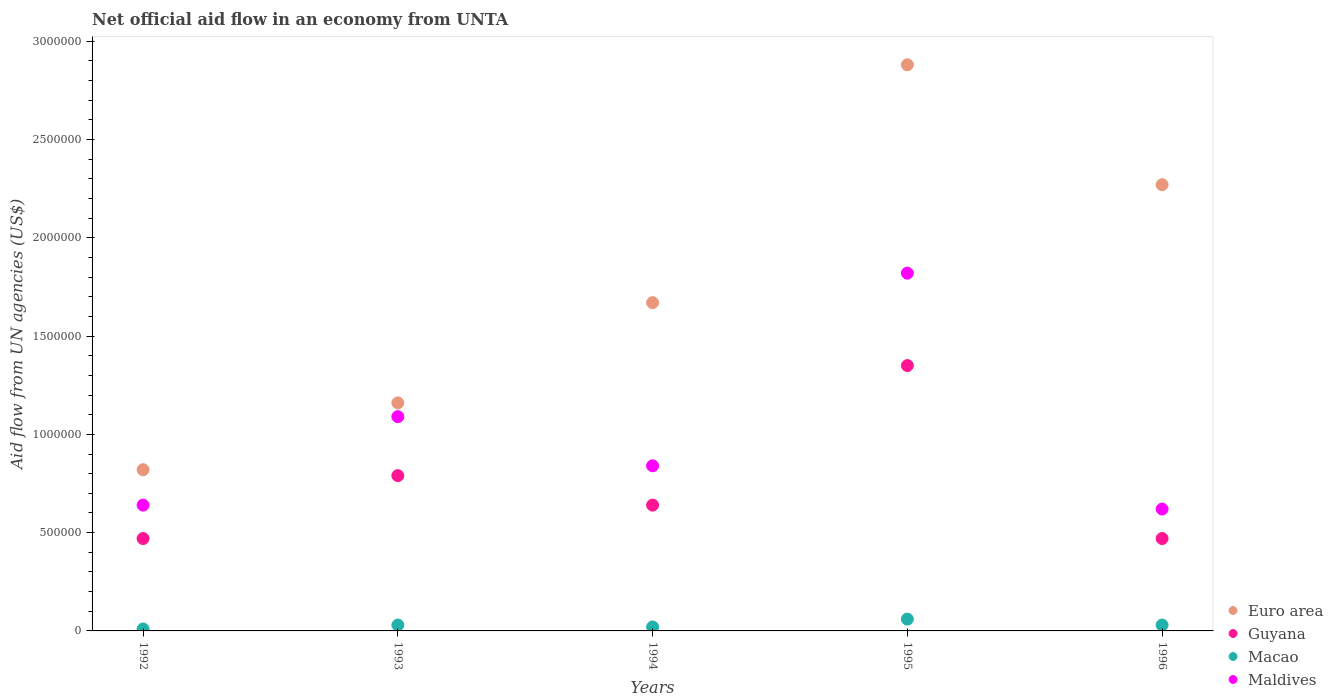What is the net official aid flow in Macao in 1993?
Make the answer very short. 3.00e+04. Across all years, what is the maximum net official aid flow in Guyana?
Ensure brevity in your answer.  1.35e+06. Across all years, what is the minimum net official aid flow in Maldives?
Give a very brief answer. 6.20e+05. In which year was the net official aid flow in Guyana maximum?
Ensure brevity in your answer.  1995. In which year was the net official aid flow in Guyana minimum?
Give a very brief answer. 1992. What is the total net official aid flow in Guyana in the graph?
Keep it short and to the point. 3.72e+06. What is the difference between the net official aid flow in Maldives in 1994 and that in 1995?
Provide a short and direct response. -9.80e+05. What is the difference between the net official aid flow in Guyana in 1994 and the net official aid flow in Macao in 1996?
Offer a very short reply. 6.10e+05. What is the average net official aid flow in Maldives per year?
Your answer should be compact. 1.00e+06. What is the ratio of the net official aid flow in Maldives in 1992 to that in 1996?
Your answer should be compact. 1.03. Is the difference between the net official aid flow in Maldives in 1993 and 1995 greater than the difference between the net official aid flow in Guyana in 1993 and 1995?
Your response must be concise. No. What is the difference between the highest and the second highest net official aid flow in Macao?
Offer a very short reply. 3.00e+04. Does the net official aid flow in Guyana monotonically increase over the years?
Provide a succinct answer. No. How many years are there in the graph?
Your response must be concise. 5. Where does the legend appear in the graph?
Offer a very short reply. Bottom right. What is the title of the graph?
Ensure brevity in your answer.  Net official aid flow in an economy from UNTA. Does "Poland" appear as one of the legend labels in the graph?
Offer a very short reply. No. What is the label or title of the Y-axis?
Give a very brief answer. Aid flow from UN agencies (US$). What is the Aid flow from UN agencies (US$) in Euro area in 1992?
Make the answer very short. 8.20e+05. What is the Aid flow from UN agencies (US$) of Guyana in 1992?
Your response must be concise. 4.70e+05. What is the Aid flow from UN agencies (US$) in Macao in 1992?
Give a very brief answer. 10000. What is the Aid flow from UN agencies (US$) of Maldives in 1992?
Your answer should be compact. 6.40e+05. What is the Aid flow from UN agencies (US$) in Euro area in 1993?
Provide a short and direct response. 1.16e+06. What is the Aid flow from UN agencies (US$) of Guyana in 1993?
Offer a very short reply. 7.90e+05. What is the Aid flow from UN agencies (US$) of Maldives in 1993?
Offer a very short reply. 1.09e+06. What is the Aid flow from UN agencies (US$) in Euro area in 1994?
Your response must be concise. 1.67e+06. What is the Aid flow from UN agencies (US$) in Guyana in 1994?
Keep it short and to the point. 6.40e+05. What is the Aid flow from UN agencies (US$) in Maldives in 1994?
Your answer should be very brief. 8.40e+05. What is the Aid flow from UN agencies (US$) in Euro area in 1995?
Your answer should be compact. 2.88e+06. What is the Aid flow from UN agencies (US$) of Guyana in 1995?
Your answer should be compact. 1.35e+06. What is the Aid flow from UN agencies (US$) of Macao in 1995?
Make the answer very short. 6.00e+04. What is the Aid flow from UN agencies (US$) in Maldives in 1995?
Make the answer very short. 1.82e+06. What is the Aid flow from UN agencies (US$) of Euro area in 1996?
Make the answer very short. 2.27e+06. What is the Aid flow from UN agencies (US$) of Macao in 1996?
Make the answer very short. 3.00e+04. What is the Aid flow from UN agencies (US$) in Maldives in 1996?
Give a very brief answer. 6.20e+05. Across all years, what is the maximum Aid flow from UN agencies (US$) of Euro area?
Offer a very short reply. 2.88e+06. Across all years, what is the maximum Aid flow from UN agencies (US$) of Guyana?
Keep it short and to the point. 1.35e+06. Across all years, what is the maximum Aid flow from UN agencies (US$) in Macao?
Your answer should be compact. 6.00e+04. Across all years, what is the maximum Aid flow from UN agencies (US$) in Maldives?
Your response must be concise. 1.82e+06. Across all years, what is the minimum Aid flow from UN agencies (US$) of Euro area?
Make the answer very short. 8.20e+05. Across all years, what is the minimum Aid flow from UN agencies (US$) of Guyana?
Provide a succinct answer. 4.70e+05. Across all years, what is the minimum Aid flow from UN agencies (US$) of Macao?
Offer a terse response. 10000. Across all years, what is the minimum Aid flow from UN agencies (US$) of Maldives?
Provide a short and direct response. 6.20e+05. What is the total Aid flow from UN agencies (US$) in Euro area in the graph?
Provide a short and direct response. 8.80e+06. What is the total Aid flow from UN agencies (US$) in Guyana in the graph?
Keep it short and to the point. 3.72e+06. What is the total Aid flow from UN agencies (US$) of Macao in the graph?
Your response must be concise. 1.50e+05. What is the total Aid flow from UN agencies (US$) of Maldives in the graph?
Keep it short and to the point. 5.01e+06. What is the difference between the Aid flow from UN agencies (US$) of Euro area in 1992 and that in 1993?
Ensure brevity in your answer.  -3.40e+05. What is the difference between the Aid flow from UN agencies (US$) in Guyana in 1992 and that in 1993?
Make the answer very short. -3.20e+05. What is the difference between the Aid flow from UN agencies (US$) of Macao in 1992 and that in 1993?
Ensure brevity in your answer.  -2.00e+04. What is the difference between the Aid flow from UN agencies (US$) in Maldives in 1992 and that in 1993?
Offer a terse response. -4.50e+05. What is the difference between the Aid flow from UN agencies (US$) of Euro area in 1992 and that in 1994?
Offer a terse response. -8.50e+05. What is the difference between the Aid flow from UN agencies (US$) of Guyana in 1992 and that in 1994?
Keep it short and to the point. -1.70e+05. What is the difference between the Aid flow from UN agencies (US$) of Euro area in 1992 and that in 1995?
Your answer should be very brief. -2.06e+06. What is the difference between the Aid flow from UN agencies (US$) in Guyana in 1992 and that in 1995?
Make the answer very short. -8.80e+05. What is the difference between the Aid flow from UN agencies (US$) of Macao in 1992 and that in 1995?
Make the answer very short. -5.00e+04. What is the difference between the Aid flow from UN agencies (US$) of Maldives in 1992 and that in 1995?
Give a very brief answer. -1.18e+06. What is the difference between the Aid flow from UN agencies (US$) in Euro area in 1992 and that in 1996?
Offer a terse response. -1.45e+06. What is the difference between the Aid flow from UN agencies (US$) of Guyana in 1992 and that in 1996?
Ensure brevity in your answer.  0. What is the difference between the Aid flow from UN agencies (US$) in Macao in 1992 and that in 1996?
Make the answer very short. -2.00e+04. What is the difference between the Aid flow from UN agencies (US$) of Maldives in 1992 and that in 1996?
Keep it short and to the point. 2.00e+04. What is the difference between the Aid flow from UN agencies (US$) of Euro area in 1993 and that in 1994?
Give a very brief answer. -5.10e+05. What is the difference between the Aid flow from UN agencies (US$) of Guyana in 1993 and that in 1994?
Offer a terse response. 1.50e+05. What is the difference between the Aid flow from UN agencies (US$) of Euro area in 1993 and that in 1995?
Your answer should be very brief. -1.72e+06. What is the difference between the Aid flow from UN agencies (US$) in Guyana in 1993 and that in 1995?
Provide a succinct answer. -5.60e+05. What is the difference between the Aid flow from UN agencies (US$) of Macao in 1993 and that in 1995?
Provide a succinct answer. -3.00e+04. What is the difference between the Aid flow from UN agencies (US$) in Maldives in 1993 and that in 1995?
Your response must be concise. -7.30e+05. What is the difference between the Aid flow from UN agencies (US$) of Euro area in 1993 and that in 1996?
Make the answer very short. -1.11e+06. What is the difference between the Aid flow from UN agencies (US$) in Guyana in 1993 and that in 1996?
Offer a terse response. 3.20e+05. What is the difference between the Aid flow from UN agencies (US$) in Macao in 1993 and that in 1996?
Your response must be concise. 0. What is the difference between the Aid flow from UN agencies (US$) in Euro area in 1994 and that in 1995?
Your answer should be very brief. -1.21e+06. What is the difference between the Aid flow from UN agencies (US$) of Guyana in 1994 and that in 1995?
Ensure brevity in your answer.  -7.10e+05. What is the difference between the Aid flow from UN agencies (US$) of Macao in 1994 and that in 1995?
Provide a short and direct response. -4.00e+04. What is the difference between the Aid flow from UN agencies (US$) in Maldives in 1994 and that in 1995?
Ensure brevity in your answer.  -9.80e+05. What is the difference between the Aid flow from UN agencies (US$) of Euro area in 1994 and that in 1996?
Offer a very short reply. -6.00e+05. What is the difference between the Aid flow from UN agencies (US$) in Euro area in 1995 and that in 1996?
Provide a short and direct response. 6.10e+05. What is the difference between the Aid flow from UN agencies (US$) in Guyana in 1995 and that in 1996?
Keep it short and to the point. 8.80e+05. What is the difference between the Aid flow from UN agencies (US$) of Maldives in 1995 and that in 1996?
Keep it short and to the point. 1.20e+06. What is the difference between the Aid flow from UN agencies (US$) of Euro area in 1992 and the Aid flow from UN agencies (US$) of Guyana in 1993?
Offer a very short reply. 3.00e+04. What is the difference between the Aid flow from UN agencies (US$) in Euro area in 1992 and the Aid flow from UN agencies (US$) in Macao in 1993?
Provide a short and direct response. 7.90e+05. What is the difference between the Aid flow from UN agencies (US$) in Euro area in 1992 and the Aid flow from UN agencies (US$) in Maldives in 1993?
Provide a succinct answer. -2.70e+05. What is the difference between the Aid flow from UN agencies (US$) of Guyana in 1992 and the Aid flow from UN agencies (US$) of Macao in 1993?
Your answer should be very brief. 4.40e+05. What is the difference between the Aid flow from UN agencies (US$) of Guyana in 1992 and the Aid flow from UN agencies (US$) of Maldives in 1993?
Provide a short and direct response. -6.20e+05. What is the difference between the Aid flow from UN agencies (US$) in Macao in 1992 and the Aid flow from UN agencies (US$) in Maldives in 1993?
Ensure brevity in your answer.  -1.08e+06. What is the difference between the Aid flow from UN agencies (US$) in Euro area in 1992 and the Aid flow from UN agencies (US$) in Maldives in 1994?
Provide a short and direct response. -2.00e+04. What is the difference between the Aid flow from UN agencies (US$) in Guyana in 1992 and the Aid flow from UN agencies (US$) in Macao in 1994?
Offer a terse response. 4.50e+05. What is the difference between the Aid flow from UN agencies (US$) of Guyana in 1992 and the Aid flow from UN agencies (US$) of Maldives in 1994?
Provide a succinct answer. -3.70e+05. What is the difference between the Aid flow from UN agencies (US$) of Macao in 1992 and the Aid flow from UN agencies (US$) of Maldives in 1994?
Offer a terse response. -8.30e+05. What is the difference between the Aid flow from UN agencies (US$) of Euro area in 1992 and the Aid flow from UN agencies (US$) of Guyana in 1995?
Offer a very short reply. -5.30e+05. What is the difference between the Aid flow from UN agencies (US$) in Euro area in 1992 and the Aid flow from UN agencies (US$) in Macao in 1995?
Keep it short and to the point. 7.60e+05. What is the difference between the Aid flow from UN agencies (US$) of Euro area in 1992 and the Aid flow from UN agencies (US$) of Maldives in 1995?
Ensure brevity in your answer.  -1.00e+06. What is the difference between the Aid flow from UN agencies (US$) in Guyana in 1992 and the Aid flow from UN agencies (US$) in Macao in 1995?
Keep it short and to the point. 4.10e+05. What is the difference between the Aid flow from UN agencies (US$) in Guyana in 1992 and the Aid flow from UN agencies (US$) in Maldives in 1995?
Make the answer very short. -1.35e+06. What is the difference between the Aid flow from UN agencies (US$) of Macao in 1992 and the Aid flow from UN agencies (US$) of Maldives in 1995?
Ensure brevity in your answer.  -1.81e+06. What is the difference between the Aid flow from UN agencies (US$) of Euro area in 1992 and the Aid flow from UN agencies (US$) of Macao in 1996?
Your response must be concise. 7.90e+05. What is the difference between the Aid flow from UN agencies (US$) of Euro area in 1992 and the Aid flow from UN agencies (US$) of Maldives in 1996?
Your response must be concise. 2.00e+05. What is the difference between the Aid flow from UN agencies (US$) in Macao in 1992 and the Aid flow from UN agencies (US$) in Maldives in 1996?
Keep it short and to the point. -6.10e+05. What is the difference between the Aid flow from UN agencies (US$) in Euro area in 1993 and the Aid flow from UN agencies (US$) in Guyana in 1994?
Ensure brevity in your answer.  5.20e+05. What is the difference between the Aid flow from UN agencies (US$) in Euro area in 1993 and the Aid flow from UN agencies (US$) in Macao in 1994?
Offer a terse response. 1.14e+06. What is the difference between the Aid flow from UN agencies (US$) of Guyana in 1993 and the Aid flow from UN agencies (US$) of Macao in 1994?
Your response must be concise. 7.70e+05. What is the difference between the Aid flow from UN agencies (US$) in Macao in 1993 and the Aid flow from UN agencies (US$) in Maldives in 1994?
Ensure brevity in your answer.  -8.10e+05. What is the difference between the Aid flow from UN agencies (US$) of Euro area in 1993 and the Aid flow from UN agencies (US$) of Guyana in 1995?
Keep it short and to the point. -1.90e+05. What is the difference between the Aid flow from UN agencies (US$) of Euro area in 1993 and the Aid flow from UN agencies (US$) of Macao in 1995?
Keep it short and to the point. 1.10e+06. What is the difference between the Aid flow from UN agencies (US$) of Euro area in 1993 and the Aid flow from UN agencies (US$) of Maldives in 1995?
Your answer should be compact. -6.60e+05. What is the difference between the Aid flow from UN agencies (US$) of Guyana in 1993 and the Aid flow from UN agencies (US$) of Macao in 1995?
Offer a terse response. 7.30e+05. What is the difference between the Aid flow from UN agencies (US$) in Guyana in 1993 and the Aid flow from UN agencies (US$) in Maldives in 1995?
Give a very brief answer. -1.03e+06. What is the difference between the Aid flow from UN agencies (US$) of Macao in 1993 and the Aid flow from UN agencies (US$) of Maldives in 1995?
Give a very brief answer. -1.79e+06. What is the difference between the Aid flow from UN agencies (US$) in Euro area in 1993 and the Aid flow from UN agencies (US$) in Guyana in 1996?
Make the answer very short. 6.90e+05. What is the difference between the Aid flow from UN agencies (US$) of Euro area in 1993 and the Aid flow from UN agencies (US$) of Macao in 1996?
Provide a succinct answer. 1.13e+06. What is the difference between the Aid flow from UN agencies (US$) of Euro area in 1993 and the Aid flow from UN agencies (US$) of Maldives in 1996?
Provide a short and direct response. 5.40e+05. What is the difference between the Aid flow from UN agencies (US$) in Guyana in 1993 and the Aid flow from UN agencies (US$) in Macao in 1996?
Offer a terse response. 7.60e+05. What is the difference between the Aid flow from UN agencies (US$) of Macao in 1993 and the Aid flow from UN agencies (US$) of Maldives in 1996?
Give a very brief answer. -5.90e+05. What is the difference between the Aid flow from UN agencies (US$) of Euro area in 1994 and the Aid flow from UN agencies (US$) of Guyana in 1995?
Make the answer very short. 3.20e+05. What is the difference between the Aid flow from UN agencies (US$) of Euro area in 1994 and the Aid flow from UN agencies (US$) of Macao in 1995?
Give a very brief answer. 1.61e+06. What is the difference between the Aid flow from UN agencies (US$) of Euro area in 1994 and the Aid flow from UN agencies (US$) of Maldives in 1995?
Ensure brevity in your answer.  -1.50e+05. What is the difference between the Aid flow from UN agencies (US$) of Guyana in 1994 and the Aid flow from UN agencies (US$) of Macao in 1995?
Your response must be concise. 5.80e+05. What is the difference between the Aid flow from UN agencies (US$) of Guyana in 1994 and the Aid flow from UN agencies (US$) of Maldives in 1995?
Provide a short and direct response. -1.18e+06. What is the difference between the Aid flow from UN agencies (US$) in Macao in 1994 and the Aid flow from UN agencies (US$) in Maldives in 1995?
Your answer should be compact. -1.80e+06. What is the difference between the Aid flow from UN agencies (US$) of Euro area in 1994 and the Aid flow from UN agencies (US$) of Guyana in 1996?
Provide a short and direct response. 1.20e+06. What is the difference between the Aid flow from UN agencies (US$) of Euro area in 1994 and the Aid flow from UN agencies (US$) of Macao in 1996?
Make the answer very short. 1.64e+06. What is the difference between the Aid flow from UN agencies (US$) in Euro area in 1994 and the Aid flow from UN agencies (US$) in Maldives in 1996?
Give a very brief answer. 1.05e+06. What is the difference between the Aid flow from UN agencies (US$) of Guyana in 1994 and the Aid flow from UN agencies (US$) of Macao in 1996?
Keep it short and to the point. 6.10e+05. What is the difference between the Aid flow from UN agencies (US$) of Guyana in 1994 and the Aid flow from UN agencies (US$) of Maldives in 1996?
Make the answer very short. 2.00e+04. What is the difference between the Aid flow from UN agencies (US$) of Macao in 1994 and the Aid flow from UN agencies (US$) of Maldives in 1996?
Give a very brief answer. -6.00e+05. What is the difference between the Aid flow from UN agencies (US$) in Euro area in 1995 and the Aid flow from UN agencies (US$) in Guyana in 1996?
Your response must be concise. 2.41e+06. What is the difference between the Aid flow from UN agencies (US$) of Euro area in 1995 and the Aid flow from UN agencies (US$) of Macao in 1996?
Make the answer very short. 2.85e+06. What is the difference between the Aid flow from UN agencies (US$) of Euro area in 1995 and the Aid flow from UN agencies (US$) of Maldives in 1996?
Offer a very short reply. 2.26e+06. What is the difference between the Aid flow from UN agencies (US$) in Guyana in 1995 and the Aid flow from UN agencies (US$) in Macao in 1996?
Offer a terse response. 1.32e+06. What is the difference between the Aid flow from UN agencies (US$) in Guyana in 1995 and the Aid flow from UN agencies (US$) in Maldives in 1996?
Your answer should be very brief. 7.30e+05. What is the difference between the Aid flow from UN agencies (US$) in Macao in 1995 and the Aid flow from UN agencies (US$) in Maldives in 1996?
Provide a short and direct response. -5.60e+05. What is the average Aid flow from UN agencies (US$) of Euro area per year?
Offer a very short reply. 1.76e+06. What is the average Aid flow from UN agencies (US$) of Guyana per year?
Keep it short and to the point. 7.44e+05. What is the average Aid flow from UN agencies (US$) in Maldives per year?
Your response must be concise. 1.00e+06. In the year 1992, what is the difference between the Aid flow from UN agencies (US$) of Euro area and Aid flow from UN agencies (US$) of Macao?
Ensure brevity in your answer.  8.10e+05. In the year 1992, what is the difference between the Aid flow from UN agencies (US$) of Euro area and Aid flow from UN agencies (US$) of Maldives?
Your answer should be compact. 1.80e+05. In the year 1992, what is the difference between the Aid flow from UN agencies (US$) in Guyana and Aid flow from UN agencies (US$) in Maldives?
Offer a very short reply. -1.70e+05. In the year 1992, what is the difference between the Aid flow from UN agencies (US$) of Macao and Aid flow from UN agencies (US$) of Maldives?
Provide a succinct answer. -6.30e+05. In the year 1993, what is the difference between the Aid flow from UN agencies (US$) in Euro area and Aid flow from UN agencies (US$) in Guyana?
Give a very brief answer. 3.70e+05. In the year 1993, what is the difference between the Aid flow from UN agencies (US$) of Euro area and Aid flow from UN agencies (US$) of Macao?
Give a very brief answer. 1.13e+06. In the year 1993, what is the difference between the Aid flow from UN agencies (US$) of Euro area and Aid flow from UN agencies (US$) of Maldives?
Offer a terse response. 7.00e+04. In the year 1993, what is the difference between the Aid flow from UN agencies (US$) of Guyana and Aid flow from UN agencies (US$) of Macao?
Offer a terse response. 7.60e+05. In the year 1993, what is the difference between the Aid flow from UN agencies (US$) of Guyana and Aid flow from UN agencies (US$) of Maldives?
Make the answer very short. -3.00e+05. In the year 1993, what is the difference between the Aid flow from UN agencies (US$) in Macao and Aid flow from UN agencies (US$) in Maldives?
Make the answer very short. -1.06e+06. In the year 1994, what is the difference between the Aid flow from UN agencies (US$) in Euro area and Aid flow from UN agencies (US$) in Guyana?
Keep it short and to the point. 1.03e+06. In the year 1994, what is the difference between the Aid flow from UN agencies (US$) in Euro area and Aid flow from UN agencies (US$) in Macao?
Offer a terse response. 1.65e+06. In the year 1994, what is the difference between the Aid flow from UN agencies (US$) in Euro area and Aid flow from UN agencies (US$) in Maldives?
Make the answer very short. 8.30e+05. In the year 1994, what is the difference between the Aid flow from UN agencies (US$) of Guyana and Aid flow from UN agencies (US$) of Macao?
Keep it short and to the point. 6.20e+05. In the year 1994, what is the difference between the Aid flow from UN agencies (US$) of Macao and Aid flow from UN agencies (US$) of Maldives?
Your response must be concise. -8.20e+05. In the year 1995, what is the difference between the Aid flow from UN agencies (US$) of Euro area and Aid flow from UN agencies (US$) of Guyana?
Keep it short and to the point. 1.53e+06. In the year 1995, what is the difference between the Aid flow from UN agencies (US$) of Euro area and Aid flow from UN agencies (US$) of Macao?
Offer a terse response. 2.82e+06. In the year 1995, what is the difference between the Aid flow from UN agencies (US$) in Euro area and Aid flow from UN agencies (US$) in Maldives?
Give a very brief answer. 1.06e+06. In the year 1995, what is the difference between the Aid flow from UN agencies (US$) of Guyana and Aid flow from UN agencies (US$) of Macao?
Give a very brief answer. 1.29e+06. In the year 1995, what is the difference between the Aid flow from UN agencies (US$) in Guyana and Aid flow from UN agencies (US$) in Maldives?
Give a very brief answer. -4.70e+05. In the year 1995, what is the difference between the Aid flow from UN agencies (US$) of Macao and Aid flow from UN agencies (US$) of Maldives?
Give a very brief answer. -1.76e+06. In the year 1996, what is the difference between the Aid flow from UN agencies (US$) in Euro area and Aid flow from UN agencies (US$) in Guyana?
Your answer should be very brief. 1.80e+06. In the year 1996, what is the difference between the Aid flow from UN agencies (US$) of Euro area and Aid flow from UN agencies (US$) of Macao?
Your response must be concise. 2.24e+06. In the year 1996, what is the difference between the Aid flow from UN agencies (US$) of Euro area and Aid flow from UN agencies (US$) of Maldives?
Offer a very short reply. 1.65e+06. In the year 1996, what is the difference between the Aid flow from UN agencies (US$) in Macao and Aid flow from UN agencies (US$) in Maldives?
Provide a short and direct response. -5.90e+05. What is the ratio of the Aid flow from UN agencies (US$) of Euro area in 1992 to that in 1993?
Your response must be concise. 0.71. What is the ratio of the Aid flow from UN agencies (US$) in Guyana in 1992 to that in 1993?
Your answer should be very brief. 0.59. What is the ratio of the Aid flow from UN agencies (US$) in Macao in 1992 to that in 1993?
Offer a very short reply. 0.33. What is the ratio of the Aid flow from UN agencies (US$) of Maldives in 1992 to that in 1993?
Offer a very short reply. 0.59. What is the ratio of the Aid flow from UN agencies (US$) in Euro area in 1992 to that in 1994?
Provide a succinct answer. 0.49. What is the ratio of the Aid flow from UN agencies (US$) of Guyana in 1992 to that in 1994?
Keep it short and to the point. 0.73. What is the ratio of the Aid flow from UN agencies (US$) of Macao in 1992 to that in 1994?
Provide a succinct answer. 0.5. What is the ratio of the Aid flow from UN agencies (US$) of Maldives in 1992 to that in 1994?
Offer a terse response. 0.76. What is the ratio of the Aid flow from UN agencies (US$) of Euro area in 1992 to that in 1995?
Your answer should be compact. 0.28. What is the ratio of the Aid flow from UN agencies (US$) in Guyana in 1992 to that in 1995?
Make the answer very short. 0.35. What is the ratio of the Aid flow from UN agencies (US$) of Maldives in 1992 to that in 1995?
Your answer should be compact. 0.35. What is the ratio of the Aid flow from UN agencies (US$) of Euro area in 1992 to that in 1996?
Offer a terse response. 0.36. What is the ratio of the Aid flow from UN agencies (US$) in Maldives in 1992 to that in 1996?
Your response must be concise. 1.03. What is the ratio of the Aid flow from UN agencies (US$) in Euro area in 1993 to that in 1994?
Your answer should be very brief. 0.69. What is the ratio of the Aid flow from UN agencies (US$) of Guyana in 1993 to that in 1994?
Your response must be concise. 1.23. What is the ratio of the Aid flow from UN agencies (US$) of Maldives in 1993 to that in 1994?
Provide a succinct answer. 1.3. What is the ratio of the Aid flow from UN agencies (US$) of Euro area in 1993 to that in 1995?
Keep it short and to the point. 0.4. What is the ratio of the Aid flow from UN agencies (US$) in Guyana in 1993 to that in 1995?
Your answer should be compact. 0.59. What is the ratio of the Aid flow from UN agencies (US$) in Macao in 1993 to that in 1995?
Offer a terse response. 0.5. What is the ratio of the Aid flow from UN agencies (US$) of Maldives in 1993 to that in 1995?
Ensure brevity in your answer.  0.6. What is the ratio of the Aid flow from UN agencies (US$) in Euro area in 1993 to that in 1996?
Offer a very short reply. 0.51. What is the ratio of the Aid flow from UN agencies (US$) of Guyana in 1993 to that in 1996?
Provide a succinct answer. 1.68. What is the ratio of the Aid flow from UN agencies (US$) in Macao in 1993 to that in 1996?
Your response must be concise. 1. What is the ratio of the Aid flow from UN agencies (US$) in Maldives in 1993 to that in 1996?
Provide a short and direct response. 1.76. What is the ratio of the Aid flow from UN agencies (US$) in Euro area in 1994 to that in 1995?
Give a very brief answer. 0.58. What is the ratio of the Aid flow from UN agencies (US$) in Guyana in 1994 to that in 1995?
Your answer should be very brief. 0.47. What is the ratio of the Aid flow from UN agencies (US$) of Maldives in 1994 to that in 1995?
Your response must be concise. 0.46. What is the ratio of the Aid flow from UN agencies (US$) of Euro area in 1994 to that in 1996?
Your response must be concise. 0.74. What is the ratio of the Aid flow from UN agencies (US$) of Guyana in 1994 to that in 1996?
Offer a terse response. 1.36. What is the ratio of the Aid flow from UN agencies (US$) in Maldives in 1994 to that in 1996?
Provide a short and direct response. 1.35. What is the ratio of the Aid flow from UN agencies (US$) of Euro area in 1995 to that in 1996?
Give a very brief answer. 1.27. What is the ratio of the Aid flow from UN agencies (US$) in Guyana in 1995 to that in 1996?
Make the answer very short. 2.87. What is the ratio of the Aid flow from UN agencies (US$) in Macao in 1995 to that in 1996?
Make the answer very short. 2. What is the ratio of the Aid flow from UN agencies (US$) of Maldives in 1995 to that in 1996?
Your response must be concise. 2.94. What is the difference between the highest and the second highest Aid flow from UN agencies (US$) in Euro area?
Provide a short and direct response. 6.10e+05. What is the difference between the highest and the second highest Aid flow from UN agencies (US$) of Guyana?
Give a very brief answer. 5.60e+05. What is the difference between the highest and the second highest Aid flow from UN agencies (US$) of Macao?
Your answer should be compact. 3.00e+04. What is the difference between the highest and the second highest Aid flow from UN agencies (US$) of Maldives?
Ensure brevity in your answer.  7.30e+05. What is the difference between the highest and the lowest Aid flow from UN agencies (US$) of Euro area?
Your answer should be very brief. 2.06e+06. What is the difference between the highest and the lowest Aid flow from UN agencies (US$) in Guyana?
Offer a terse response. 8.80e+05. What is the difference between the highest and the lowest Aid flow from UN agencies (US$) in Maldives?
Make the answer very short. 1.20e+06. 